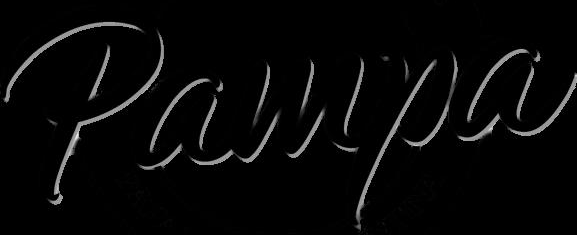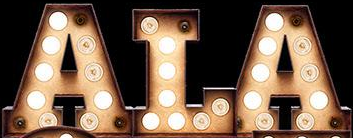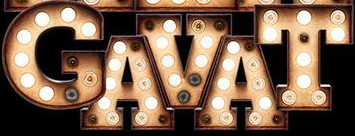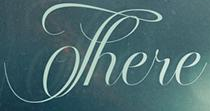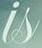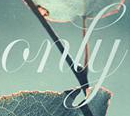What words are shown in these images in order, separated by a semicolon? Pampa; ALA; GAVAT; There; is; only 